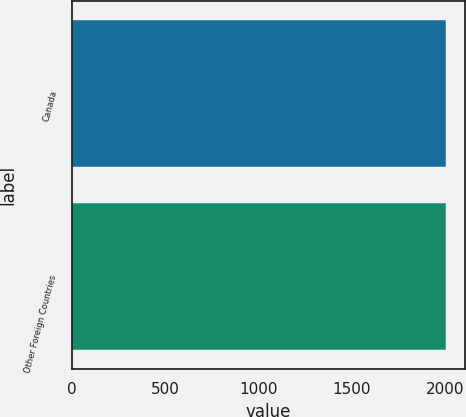Convert chart to OTSL. <chart><loc_0><loc_0><loc_500><loc_500><bar_chart><fcel>Canada<fcel>Other Foreign Countries<nl><fcel>2003<fcel>2003.1<nl></chart> 